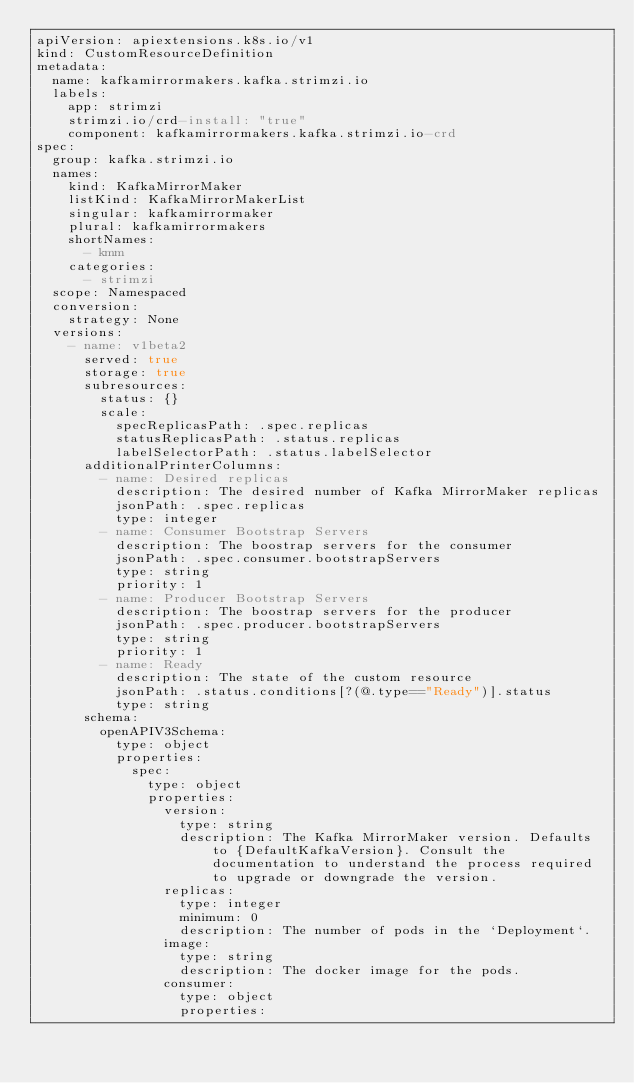<code> <loc_0><loc_0><loc_500><loc_500><_YAML_>apiVersion: apiextensions.k8s.io/v1
kind: CustomResourceDefinition
metadata:
  name: kafkamirrormakers.kafka.strimzi.io
  labels:
    app: strimzi
    strimzi.io/crd-install: "true"
    component: kafkamirrormakers.kafka.strimzi.io-crd
spec:
  group: kafka.strimzi.io
  names:
    kind: KafkaMirrorMaker
    listKind: KafkaMirrorMakerList
    singular: kafkamirrormaker
    plural: kafkamirrormakers
    shortNames:
      - kmm
    categories:
      - strimzi
  scope: Namespaced
  conversion:
    strategy: None
  versions:
    - name: v1beta2
      served: true
      storage: true
      subresources:
        status: {}
        scale:
          specReplicasPath: .spec.replicas
          statusReplicasPath: .status.replicas
          labelSelectorPath: .status.labelSelector
      additionalPrinterColumns:
        - name: Desired replicas
          description: The desired number of Kafka MirrorMaker replicas
          jsonPath: .spec.replicas
          type: integer
        - name: Consumer Bootstrap Servers
          description: The boostrap servers for the consumer
          jsonPath: .spec.consumer.bootstrapServers
          type: string
          priority: 1
        - name: Producer Bootstrap Servers
          description: The boostrap servers for the producer
          jsonPath: .spec.producer.bootstrapServers
          type: string
          priority: 1
        - name: Ready
          description: The state of the custom resource
          jsonPath: .status.conditions[?(@.type=="Ready")].status
          type: string
      schema:
        openAPIV3Schema:
          type: object
          properties:
            spec:
              type: object
              properties:
                version:
                  type: string
                  description: The Kafka MirrorMaker version. Defaults to {DefaultKafkaVersion}. Consult the documentation to understand the process required to upgrade or downgrade the version.
                replicas:
                  type: integer
                  minimum: 0
                  description: The number of pods in the `Deployment`.
                image:
                  type: string
                  description: The docker image for the pods.
                consumer:
                  type: object
                  properties:</code> 